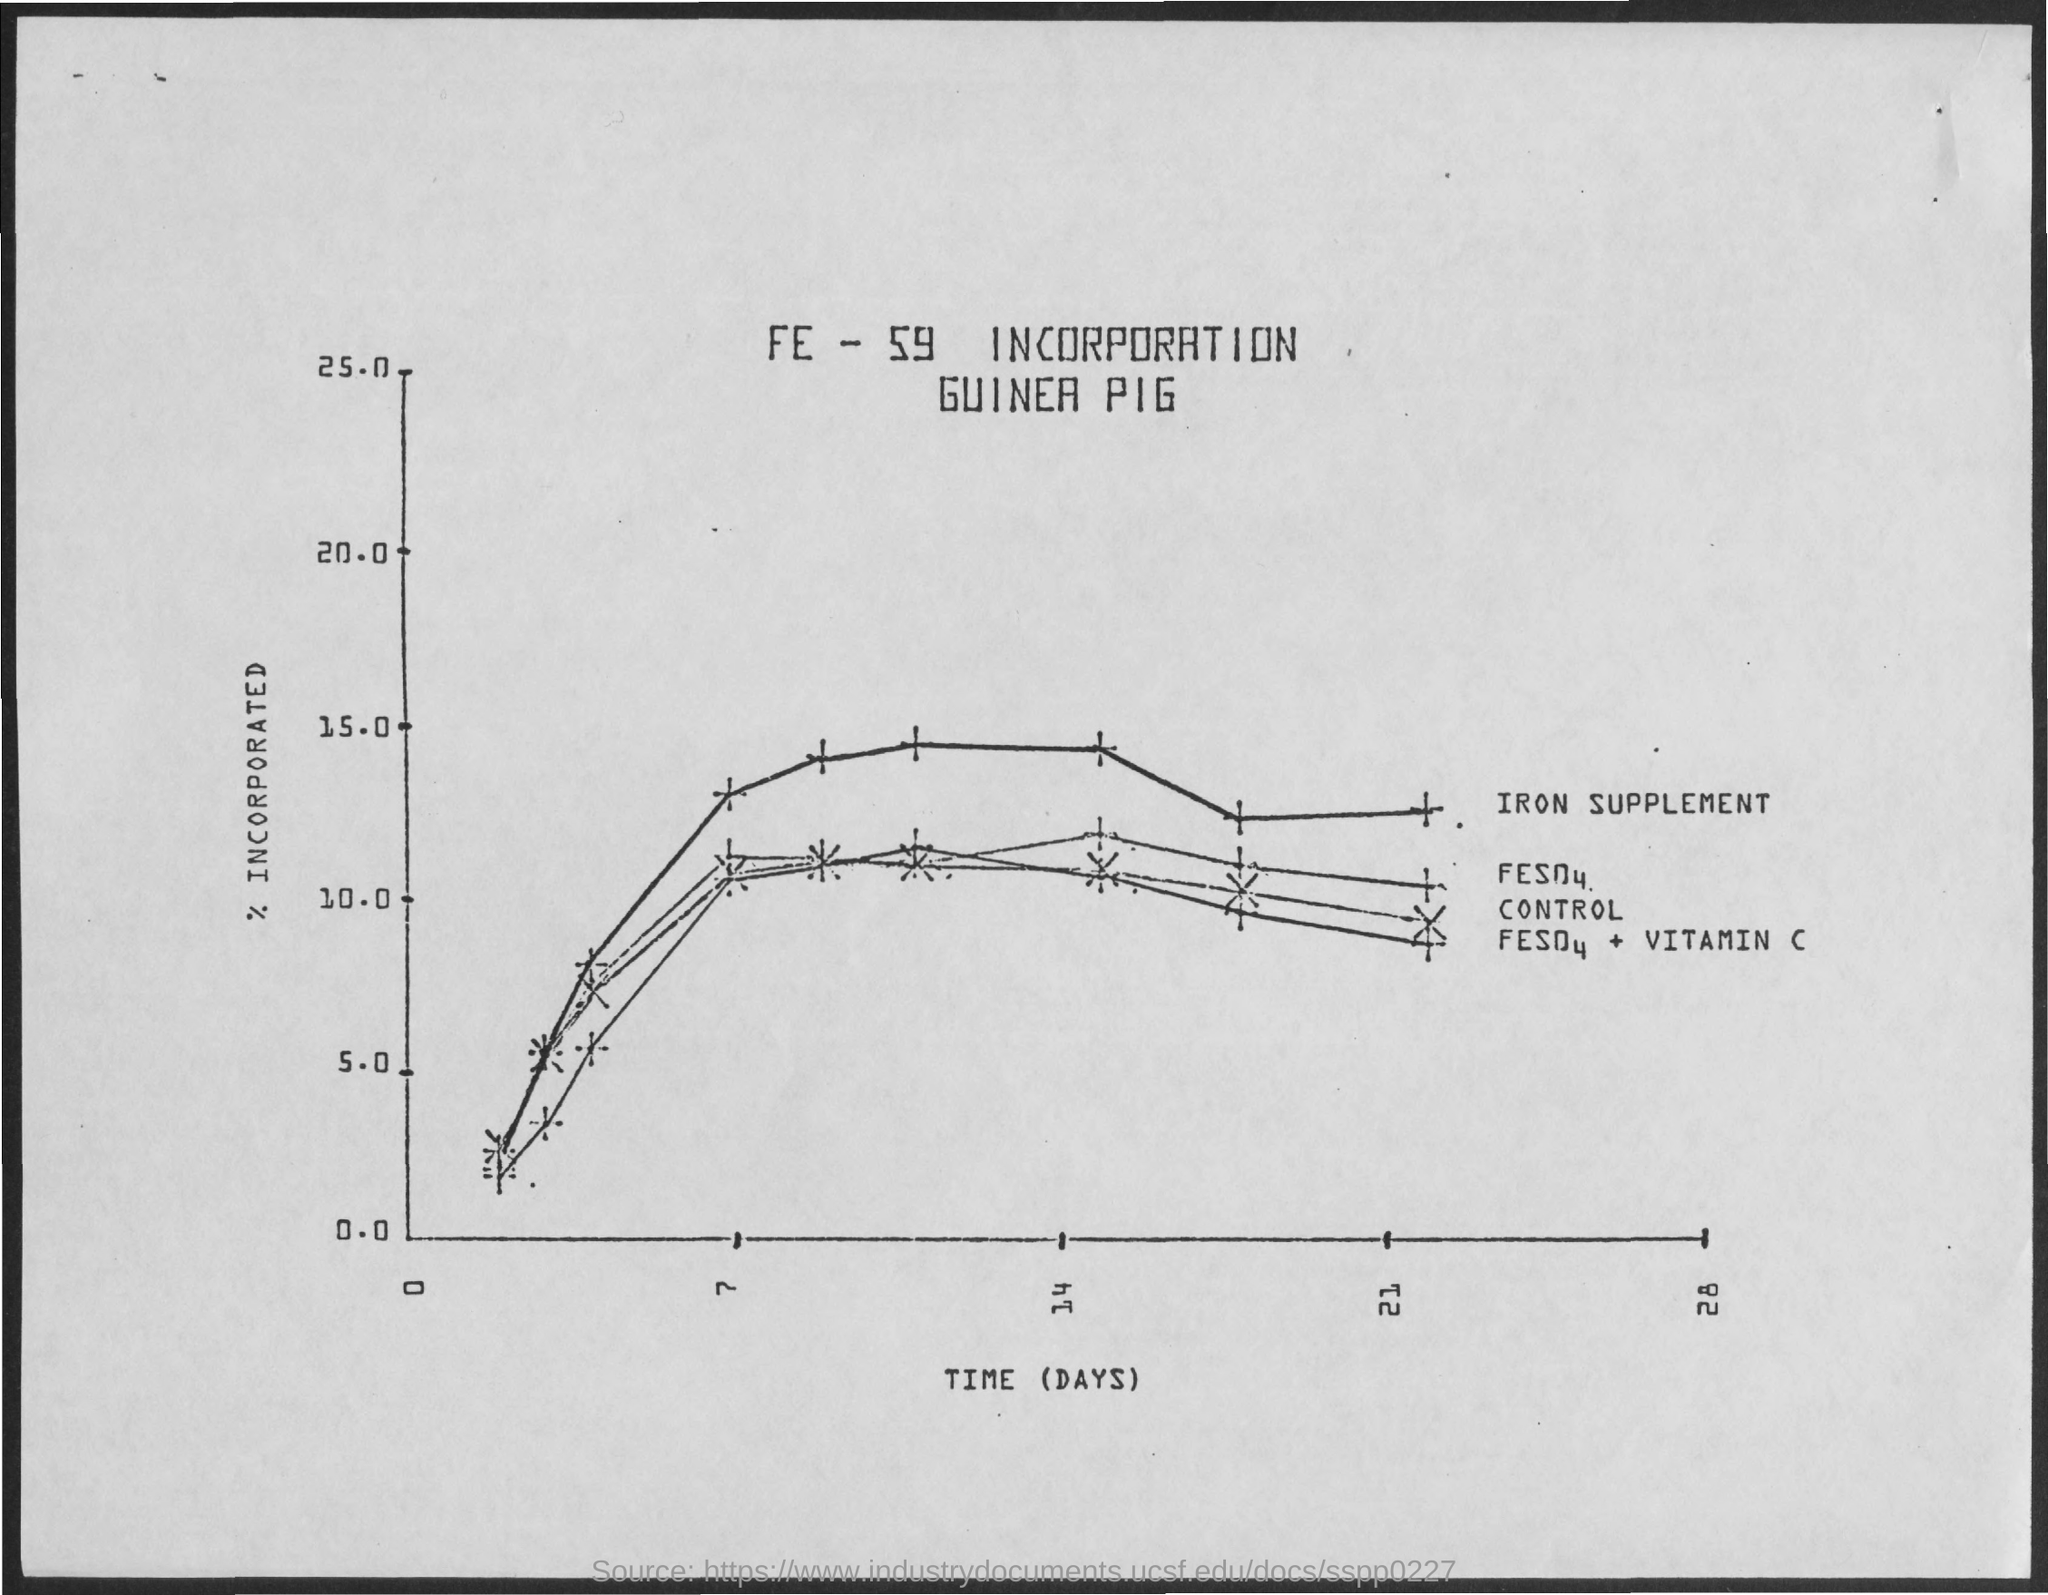What is plotted in the y-axis?
Provide a short and direct response. % incorporated. What is plotted in the x-axis?
Provide a short and direct response. Time (days). 